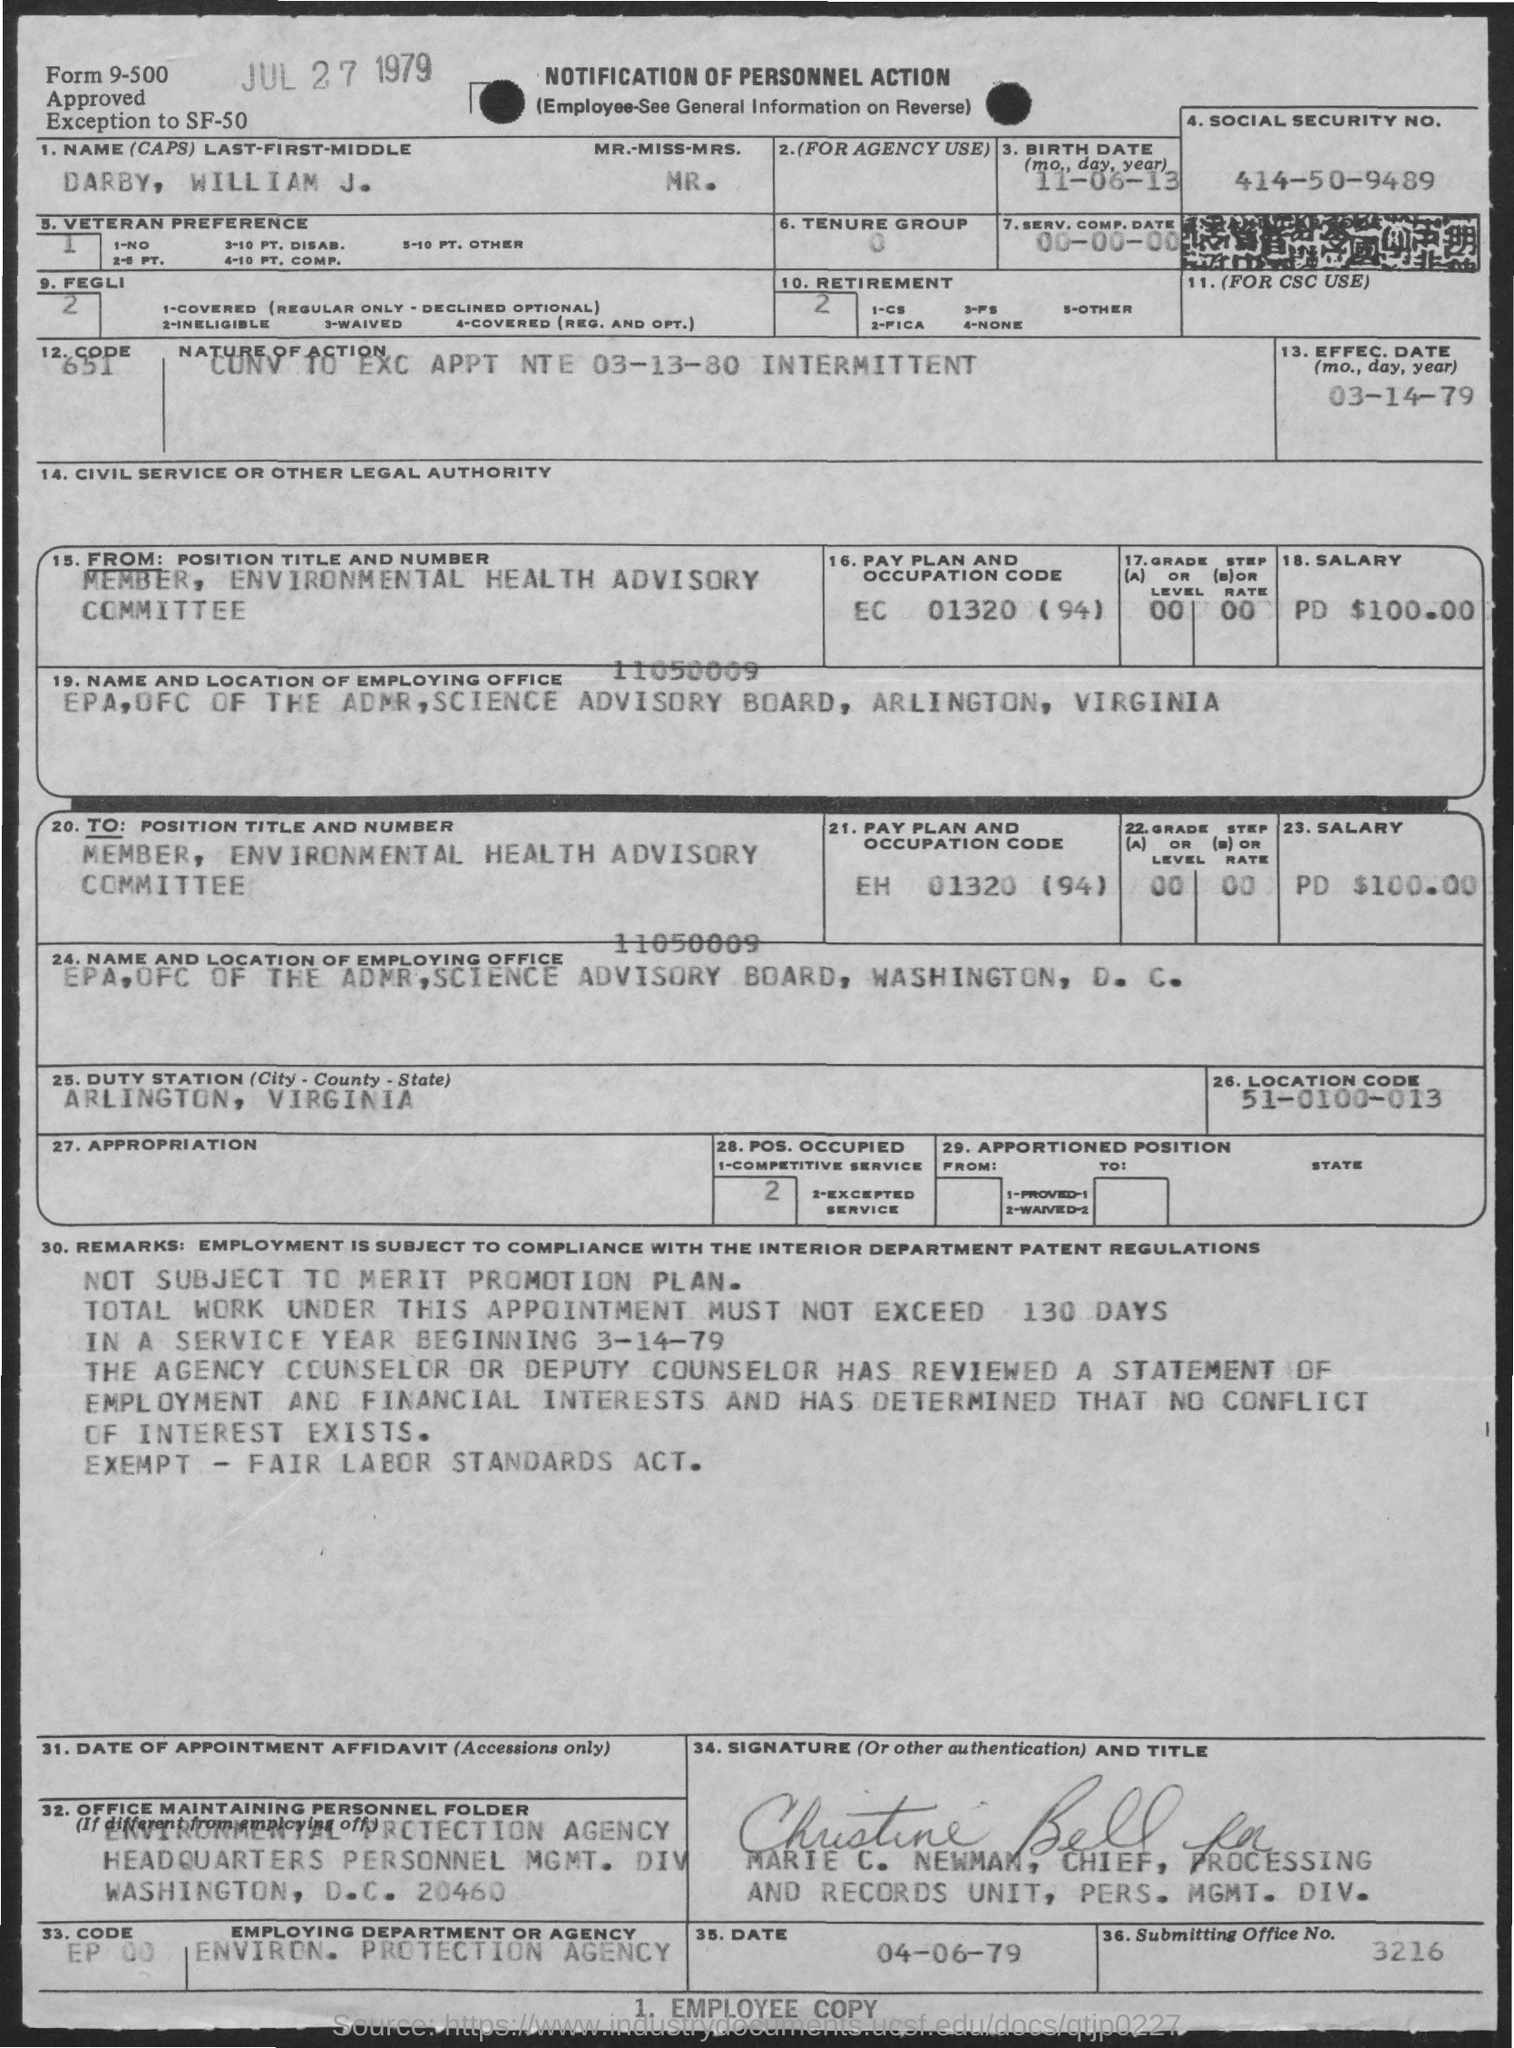What is the social security number of darby, william j.?
Ensure brevity in your answer.  414-50-9489. What is the birth date of darby, william j.?
Provide a short and direct response. 11-06-13. What is the pay plan and occupation code of darby. william j. ?
Your answer should be compact. EC 01320 (94). What is the effective date of action?
Offer a very short reply. 03-14-79. What is the duty station?
Keep it short and to the point. Arlington, Virginia. What is the location code?
Make the answer very short. 51-0100-013. What is notification about?
Your answer should be very brief. Notification of personnel action. What is the nature of action?
Your response must be concise. Conv to exc appt nte 03-13-80 intermittent. What is the position title and number?
Offer a very short reply. Member, environmental health advisory committee. What is the submitting office no.?
Your answer should be compact. 3216. 